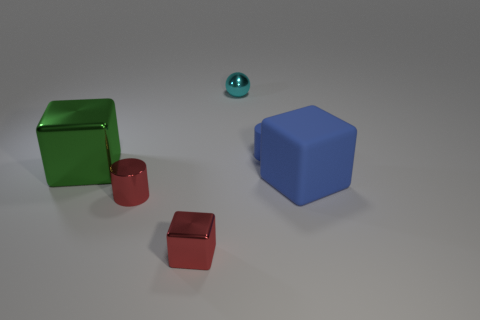Do the matte cube and the rubber cylinder have the same color?
Your answer should be compact. Yes. What color is the cube that is behind the red metal cube and left of the large matte thing?
Offer a very short reply. Green. How many other objects are the same color as the tiny metallic cube?
Your answer should be compact. 1. There is a large thing that is in front of the big green shiny cube; what color is it?
Provide a succinct answer. Blue. Are there any blue objects that have the same size as the blue rubber cylinder?
Your answer should be very brief. No. There is a blue object that is the same size as the red metallic cube; what is its material?
Offer a terse response. Rubber. How many objects are either big cubes that are on the right side of the small matte object or objects that are behind the blue cube?
Keep it short and to the point. 4. Is there another red thing of the same shape as the big shiny object?
Your answer should be very brief. Yes. What material is the small thing that is the same color as the tiny shiny cylinder?
Give a very brief answer. Metal. What number of metallic objects are either tiny red cylinders or large green cubes?
Keep it short and to the point. 2. 